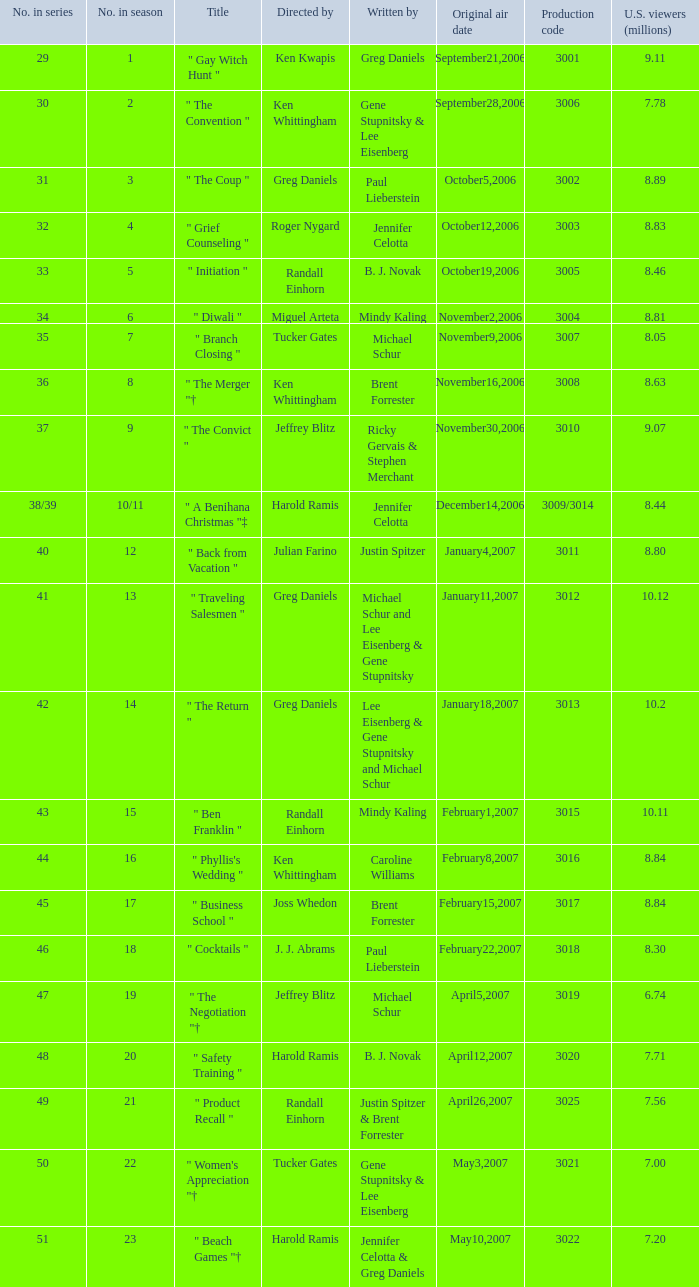Determine the numeral in the progression when the spectators are 30.0. 